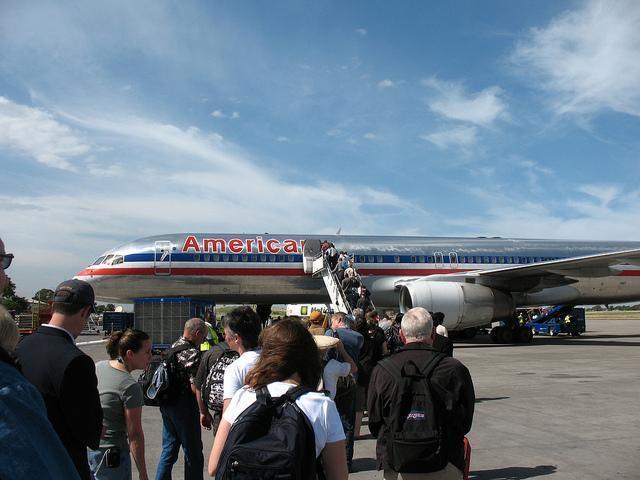How many people are there?
Give a very brief answer. 6. How many backpacks are in the photo?
Give a very brief answer. 2. 